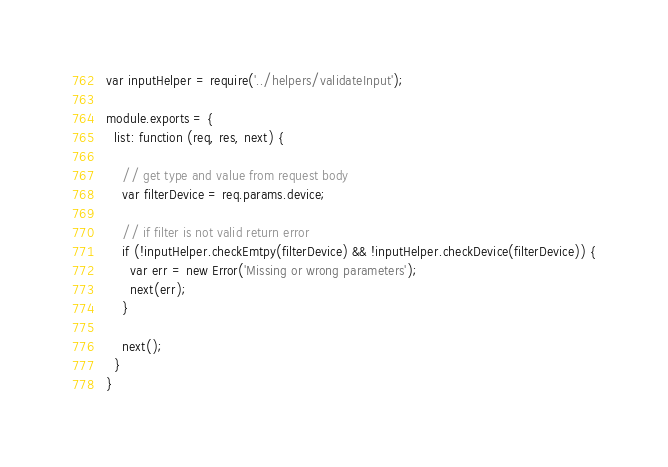<code> <loc_0><loc_0><loc_500><loc_500><_JavaScript_>var inputHelper = require('../helpers/validateInput');

module.exports = {
  list: function (req, res, next) {

    // get type and value from request body
    var filterDevice = req.params.device;

    // if filter is not valid return error
    if (!inputHelper.checkEmtpy(filterDevice) && !inputHelper.checkDevice(filterDevice)) {
      var err = new Error('Missing or wrong parameters');
      next(err);
    }

    next();
  }
}
</code> 